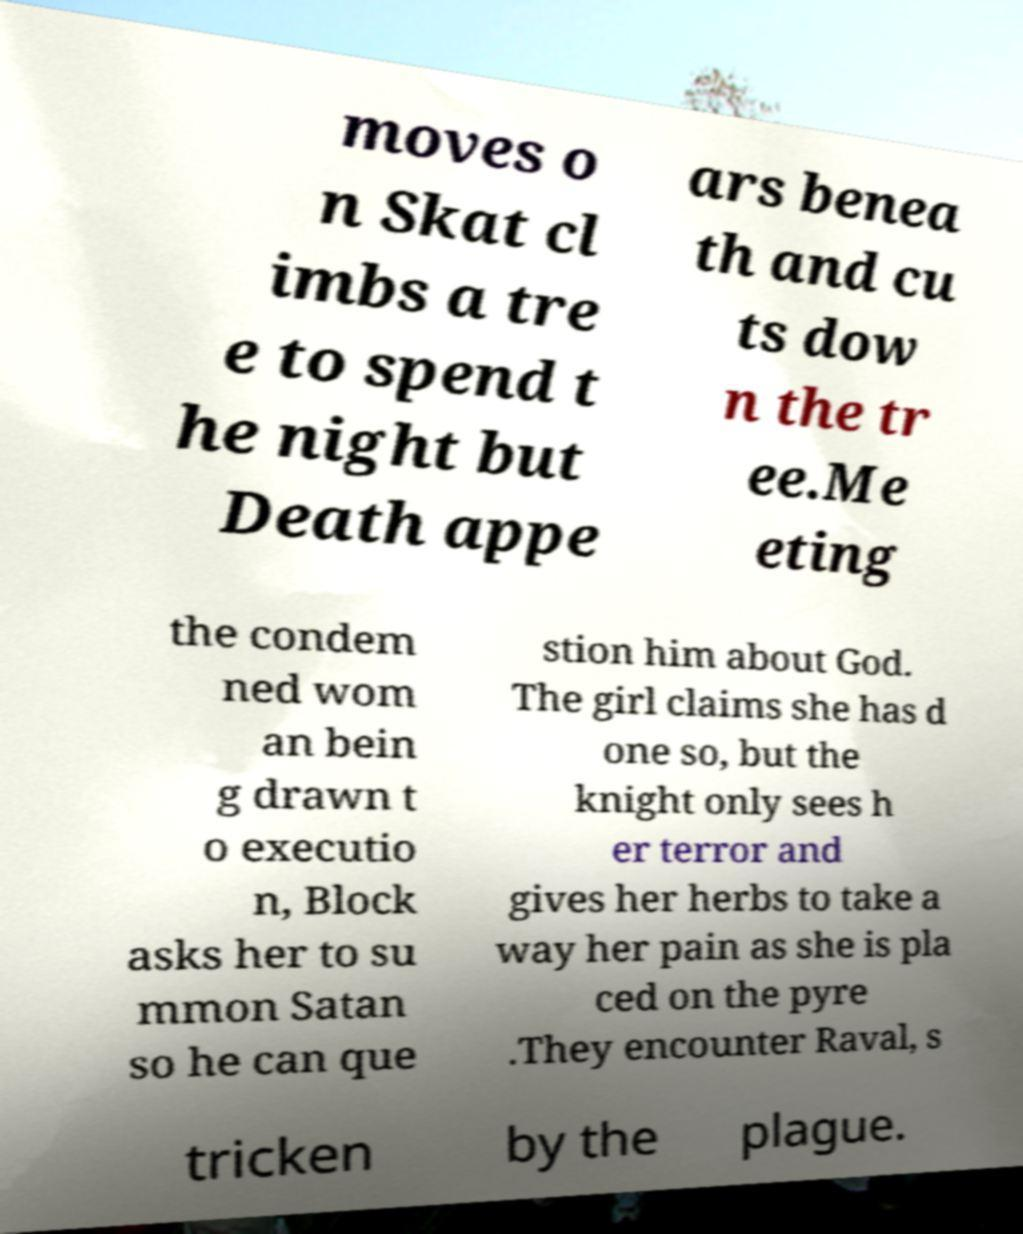What messages or text are displayed in this image? I need them in a readable, typed format. moves o n Skat cl imbs a tre e to spend t he night but Death appe ars benea th and cu ts dow n the tr ee.Me eting the condem ned wom an bein g drawn t o executio n, Block asks her to su mmon Satan so he can que stion him about God. The girl claims she has d one so, but the knight only sees h er terror and gives her herbs to take a way her pain as she is pla ced on the pyre .They encounter Raval, s tricken by the plague. 